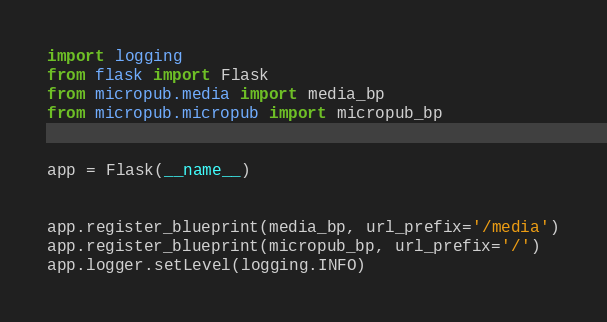Convert code to text. <code><loc_0><loc_0><loc_500><loc_500><_Python_>import logging
from flask import Flask
from micropub.media import media_bp
from micropub.micropub import micropub_bp


app = Flask(__name__)


app.register_blueprint(media_bp, url_prefix='/media')
app.register_blueprint(micropub_bp, url_prefix='/')
app.logger.setLevel(logging.INFO)
</code> 